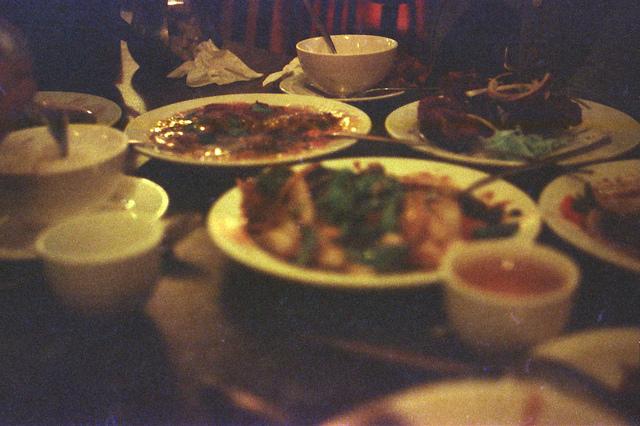What color are the dishes?
Keep it brief. White. Have any of these foods been eaten?
Be succinct. Yes. Could this meal be Asian?
Short answer required. Yes. 